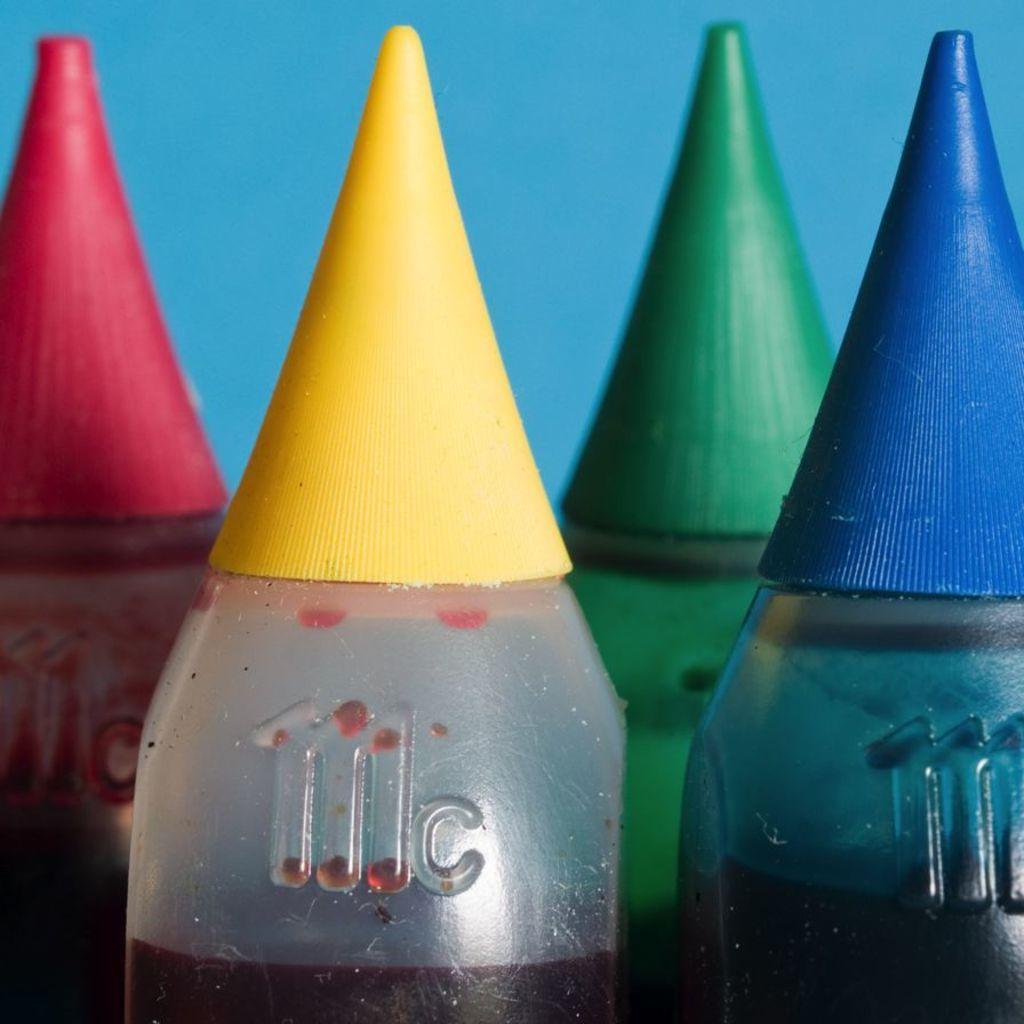Could you give a brief overview of what you see in this image? In the image we can see there are ink bottles of printer which are in yellow, green, blue and pink colour. 